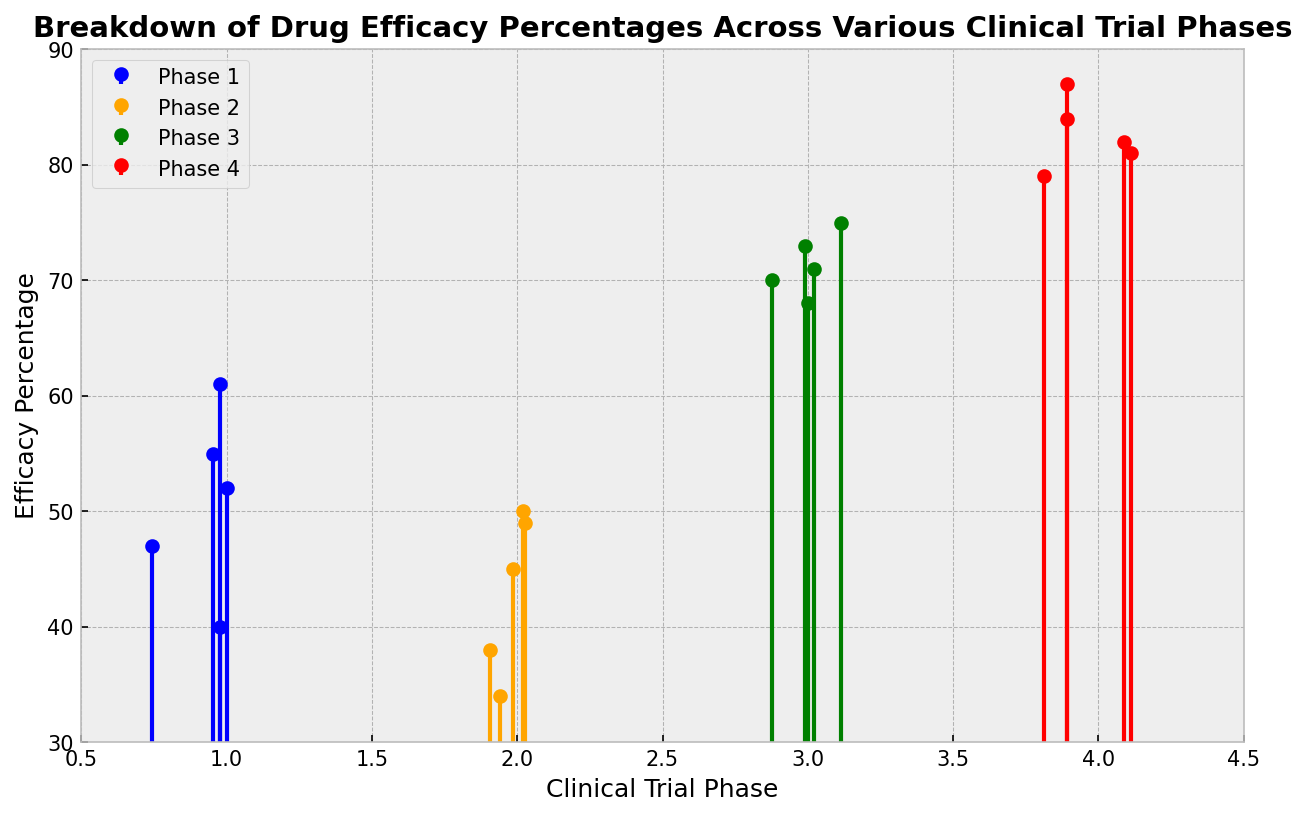Which phase has the highest average drug efficacy percentage? To find the average drug efficacy percentage for each phase, sum the percentages for each phase and then divide by the number of data points in that phase. Phase 4: (82 + 79 + 84 + 81 + 87)/5 = 413/5 = 82.6. Phase 3: (70 + 73 + 68 + 71 + 75)/5 = 357/5 = 71.4. Phase 2: (38 + 45 + 50 + 34 + 49)/5 = 216/5 = 43.2. Phase 1: (52 + 47 + 55 + 40 + 61)/5 = 255/5 = 51. Hence, phase 4 has the highest average drug efficacy percentage.
Answer: Phase 4 Which phase shows the most variability in drug efficacy percentages? To determine variability, look for the range or spread of efficacy percentages within each phase. In Phase 1, values vary between 40 and 61; in Phase 2, between 34 and 50; in Phase 3, between 68 and 75; in Phase 4, between 79 and 87. Phase 1 shows the most variability with a range of 21 (61 - 40 = 21).
Answer: Phase 1 What is the efficacy percentage difference between the highest points of Phase 4 and Phase 2? Identify the highest efficacy percentages in Phase 4 and Phase 2. Phase 4’s highest point is 87 and Phase 2’s highest point is 50. The difference between these two points is 87 - 50 = 37.
Answer: 37 Which phase has the least number of data points? Count the number of data points (efficacy percentages) for each phase. Phase 1: 5 data points, Phase 2: 5 data points, Phase 3: 5 data points, Phase 4: 5 data points. Since all phases have 5 data points, no phase has fewer data points than the others.
Answer: None In which phase is the lowest efficacy percentage observed and what is the percentage? Examine the data for the lowest efficacy percentages in each phase. Phase 1: 40, Phase 2: 34, Phase 3: 68, Phase 4: 79. The lowest efficacy percentage is observed in Phase 2, and it is 34.
Answer: Phase 2, 34 What is the median efficacy percentage for Phase 3? Sort the efficacy percentages of Phase 3: [68, 70, 71, 73, 75]. The median value is the middle value, which is the third value in the sorted list: 71.
Answer: 71 Which color represents Phase 2 in the stem plot? Each phase is represented by a specific color: Phase 1 (blue), Phase 2 (orange), Phase 3 (green), Phase 4 (red). Hence, Phase 2 is represented by the color orange.
Answer: Orange How does the highest efficacy percentage in Phase 3 compare to the lowest efficacy percentage in Phase 4? Identify the highest efficacy percentage in Phase 3 (75) and the lowest in Phase 4 (79). Since 75 is less than 79, the highest efficacy percentage in Phase 3 is lower than the lowest efficacy percentage in Phase 4.
Answer: Lower What is the average efficacy percentage for Phase 1? The efficacy percentages for Phase 1 are 52, 47, 55, 40, and 61. The average is calculated as (52 + 47 + 55 + 40 + 61)/5 = 255/5 = 51.
Answer: 51 